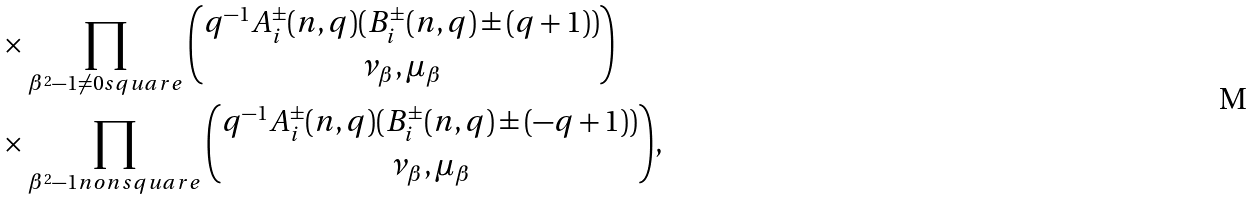<formula> <loc_0><loc_0><loc_500><loc_500>& \quad \times \prod _ { \beta ^ { 2 } - 1 \neq 0 s q u a r e } \binom { q ^ { - 1 } A _ { i } ^ { \pm } ( n , q ) ( B _ { i } ^ { \pm } ( n , q ) \pm ( q + 1 ) ) } { \nu _ { \beta } , \mu _ { \beta } } \\ & \quad \times \prod _ { \beta ^ { 2 } - 1 n o n s q u a r e } \binom { q ^ { - 1 } A _ { i } ^ { \pm } ( n , q ) ( B _ { i } ^ { \pm } ( n , q ) \pm ( - q + 1 ) ) } { \nu _ { \beta } , \mu _ { \beta } } ,</formula> 